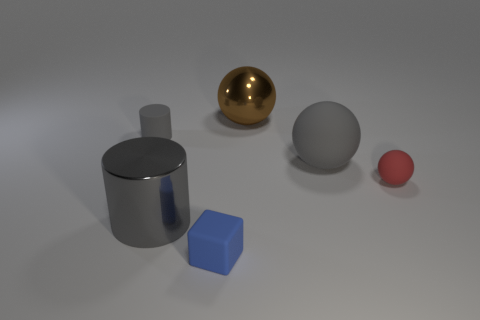Add 4 big rubber balls. How many objects exist? 10 Subtract all cylinders. How many objects are left? 4 Add 6 gray metallic cylinders. How many gray metallic cylinders exist? 7 Subtract 0 blue spheres. How many objects are left? 6 Subtract all gray spheres. Subtract all tiny matte balls. How many objects are left? 4 Add 1 red rubber things. How many red rubber things are left? 2 